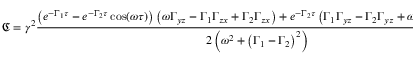Convert formula to latex. <formula><loc_0><loc_0><loc_500><loc_500>\mathfrak { C } = \gamma ^ { 2 } \frac { \left ( e ^ { - \Gamma _ { 1 } \tau } - e ^ { - \Gamma _ { 2 } \tau } \cos ( \omega \tau ) \right ) \left ( \omega \Gamma _ { y z } - \Gamma _ { 1 } \Gamma _ { z x } + \Gamma _ { 2 } \Gamma _ { z x } \right ) + e ^ { - \Gamma _ { 2 } \tau } \left ( \Gamma _ { 1 } \Gamma _ { y z } - \Gamma _ { 2 } \Gamma _ { y z } + \omega \Gamma _ { z x } \right ) \sin ( \omega \tau ) } { 2 \left ( \omega ^ { 2 } + \left ( \Gamma _ { 1 } - \Gamma _ { 2 } \right ) ^ { 2 } \right ) }</formula> 